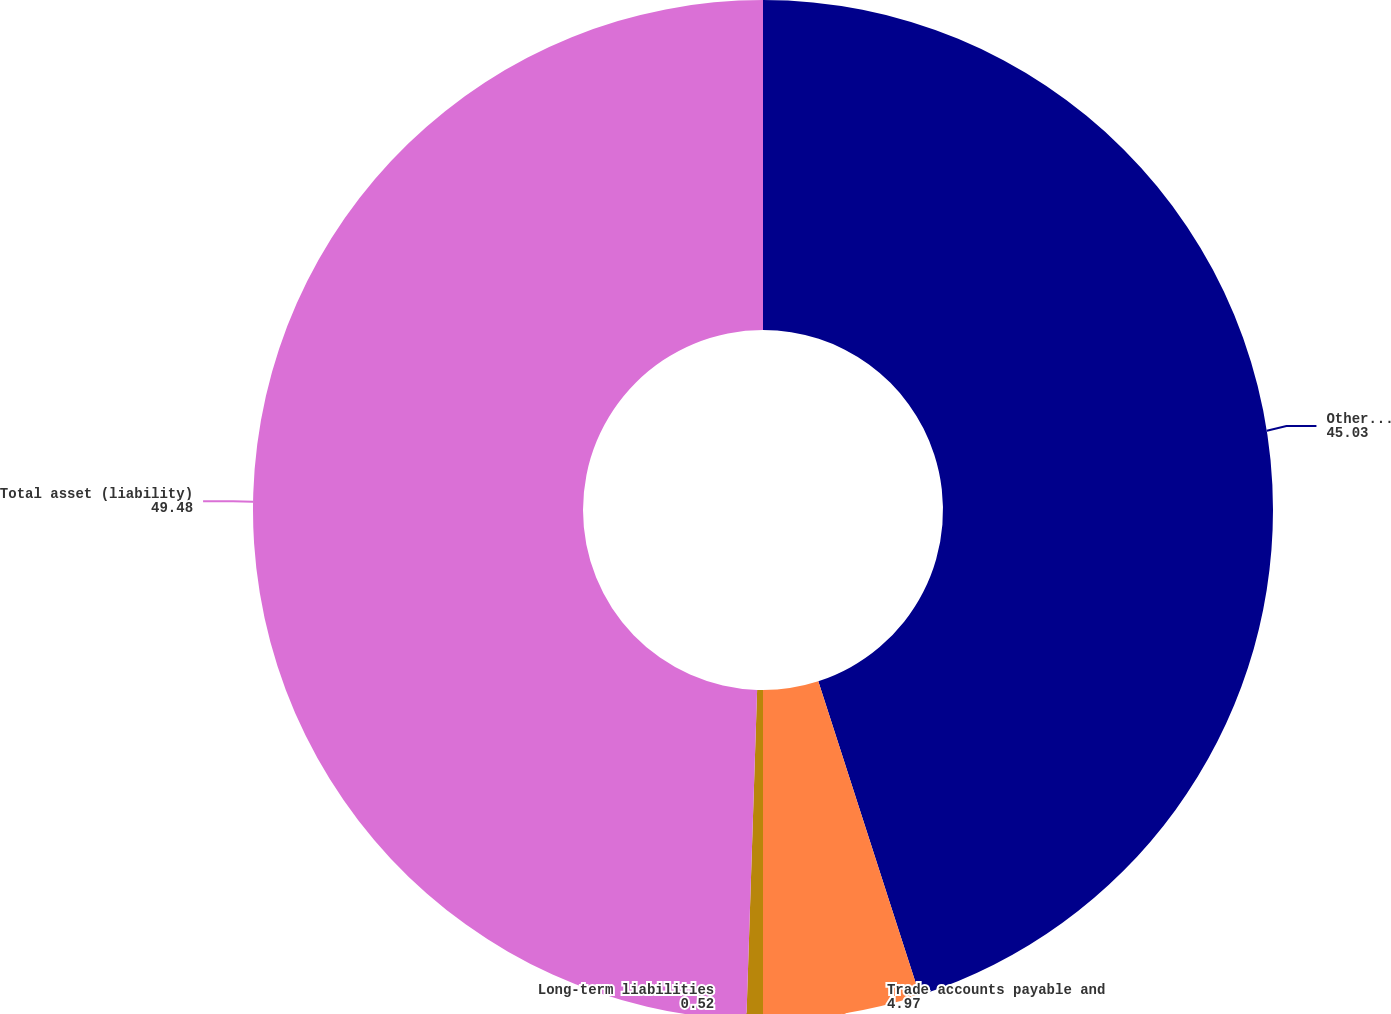<chart> <loc_0><loc_0><loc_500><loc_500><pie_chart><fcel>Other long-term assets<fcel>Trade accounts payable and<fcel>Long-term liabilities<fcel>Total asset (liability)<nl><fcel>45.03%<fcel>4.97%<fcel>0.52%<fcel>49.48%<nl></chart> 